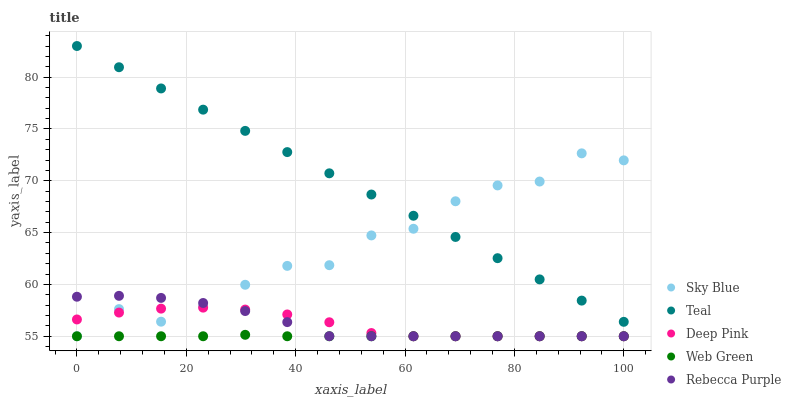Does Web Green have the minimum area under the curve?
Answer yes or no. Yes. Does Teal have the maximum area under the curve?
Answer yes or no. Yes. Does Deep Pink have the minimum area under the curve?
Answer yes or no. No. Does Deep Pink have the maximum area under the curve?
Answer yes or no. No. Is Teal the smoothest?
Answer yes or no. Yes. Is Sky Blue the roughest?
Answer yes or no. Yes. Is Deep Pink the smoothest?
Answer yes or no. No. Is Deep Pink the roughest?
Answer yes or no. No. Does Sky Blue have the lowest value?
Answer yes or no. Yes. Does Teal have the lowest value?
Answer yes or no. No. Does Teal have the highest value?
Answer yes or no. Yes. Does Deep Pink have the highest value?
Answer yes or no. No. Is Deep Pink less than Teal?
Answer yes or no. Yes. Is Teal greater than Rebecca Purple?
Answer yes or no. Yes. Does Rebecca Purple intersect Sky Blue?
Answer yes or no. Yes. Is Rebecca Purple less than Sky Blue?
Answer yes or no. No. Is Rebecca Purple greater than Sky Blue?
Answer yes or no. No. Does Deep Pink intersect Teal?
Answer yes or no. No. 